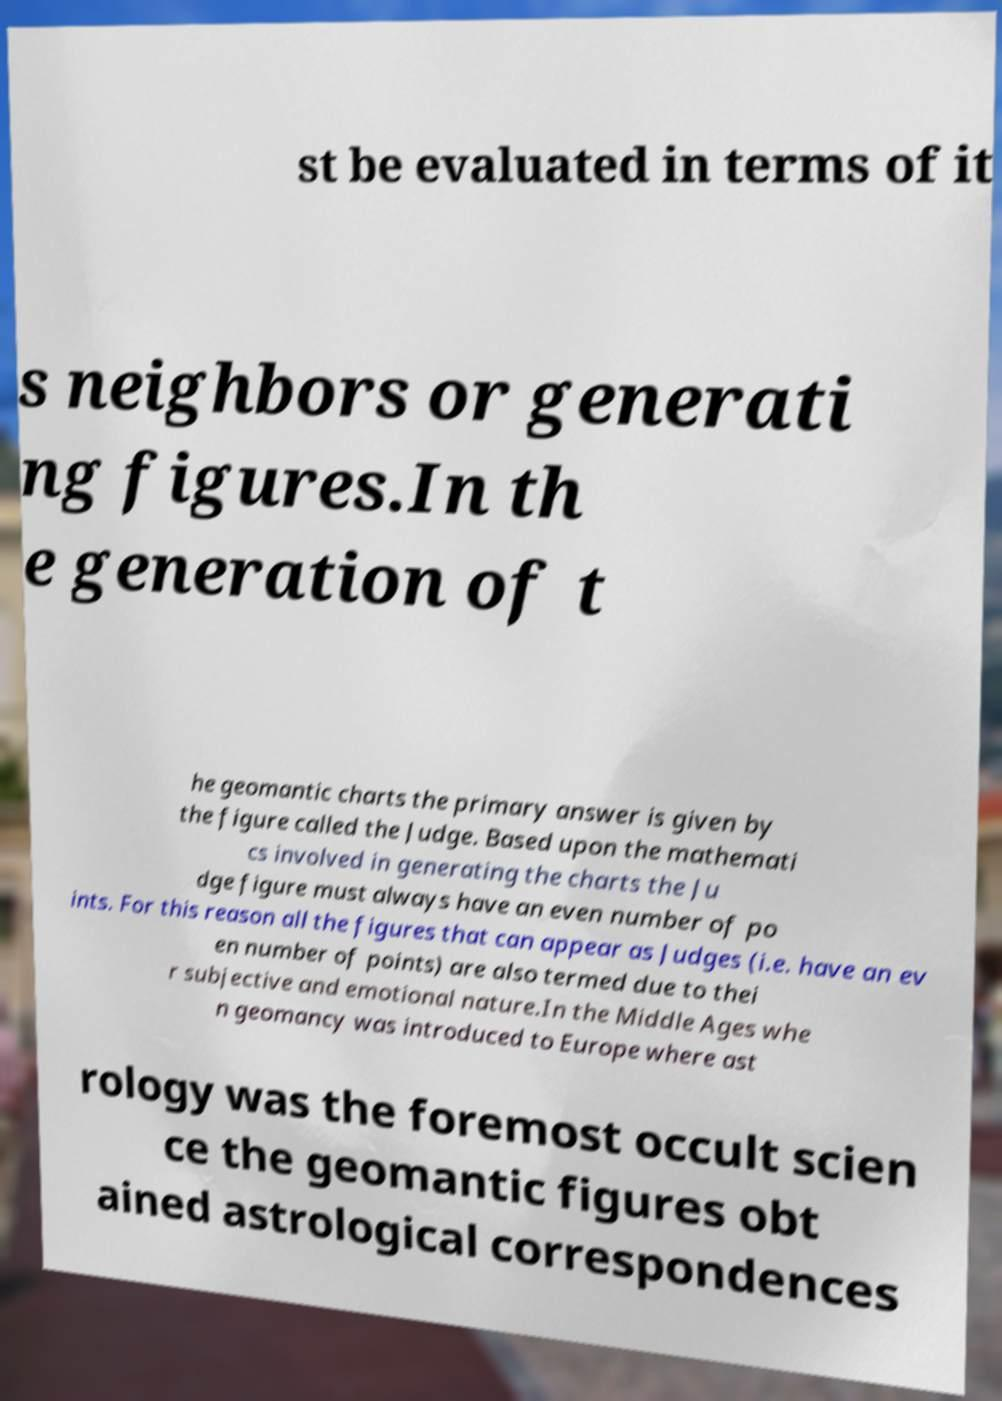Can you accurately transcribe the text from the provided image for me? st be evaluated in terms of it s neighbors or generati ng figures.In th e generation of t he geomantic charts the primary answer is given by the figure called the Judge. Based upon the mathemati cs involved in generating the charts the Ju dge figure must always have an even number of po ints. For this reason all the figures that can appear as Judges (i.e. have an ev en number of points) are also termed due to thei r subjective and emotional nature.In the Middle Ages whe n geomancy was introduced to Europe where ast rology was the foremost occult scien ce the geomantic figures obt ained astrological correspondences 